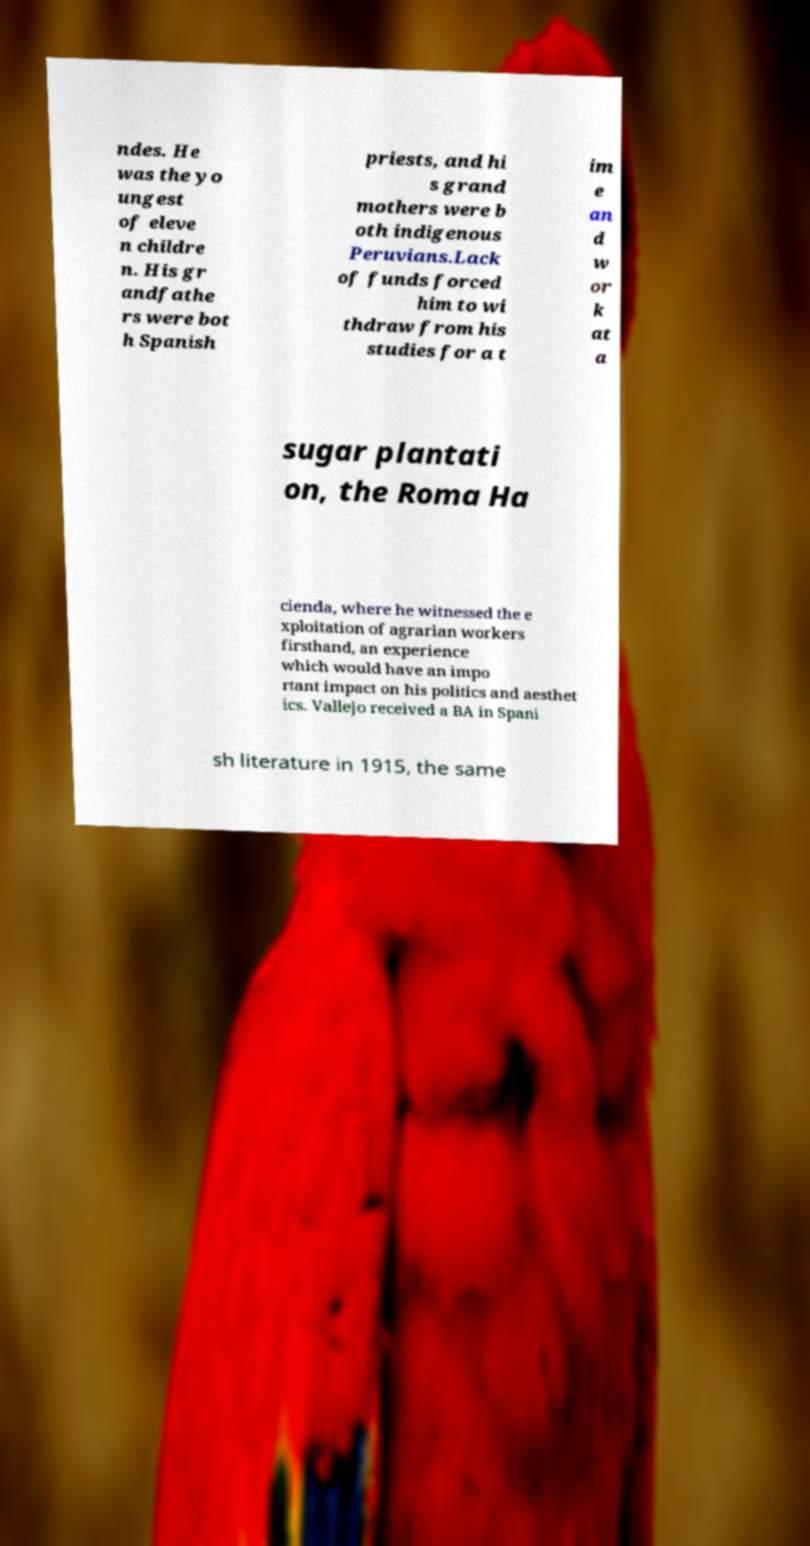What messages or text are displayed in this image? I need them in a readable, typed format. ndes. He was the yo ungest of eleve n childre n. His gr andfathe rs were bot h Spanish priests, and hi s grand mothers were b oth indigenous Peruvians.Lack of funds forced him to wi thdraw from his studies for a t im e an d w or k at a sugar plantati on, the Roma Ha cienda, where he witnessed the e xploitation of agrarian workers firsthand, an experience which would have an impo rtant impact on his politics and aesthet ics. Vallejo received a BA in Spani sh literature in 1915, the same 